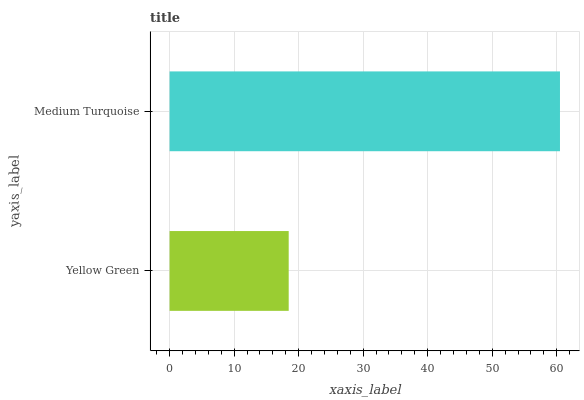Is Yellow Green the minimum?
Answer yes or no. Yes. Is Medium Turquoise the maximum?
Answer yes or no. Yes. Is Medium Turquoise the minimum?
Answer yes or no. No. Is Medium Turquoise greater than Yellow Green?
Answer yes or no. Yes. Is Yellow Green less than Medium Turquoise?
Answer yes or no. Yes. Is Yellow Green greater than Medium Turquoise?
Answer yes or no. No. Is Medium Turquoise less than Yellow Green?
Answer yes or no. No. Is Medium Turquoise the high median?
Answer yes or no. Yes. Is Yellow Green the low median?
Answer yes or no. Yes. Is Yellow Green the high median?
Answer yes or no. No. Is Medium Turquoise the low median?
Answer yes or no. No. 